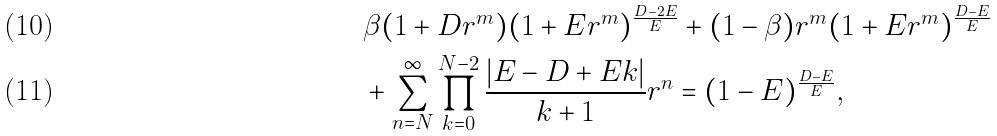<formula> <loc_0><loc_0><loc_500><loc_500>& \beta ( 1 + D r ^ { m } ) ( 1 + E r ^ { m } ) ^ { \frac { D - 2 E } { E } } + ( 1 - \beta ) r ^ { m } ( 1 + E r ^ { m } ) ^ { \frac { D - E } { E } } \\ & + \sum _ { n = N } ^ { \infty } \prod _ { k = 0 } ^ { N - 2 } \frac { | E - D + E k | } { k + 1 } r ^ { n } = ( 1 - E ) ^ { \frac { D - E } { E } } ,</formula> 